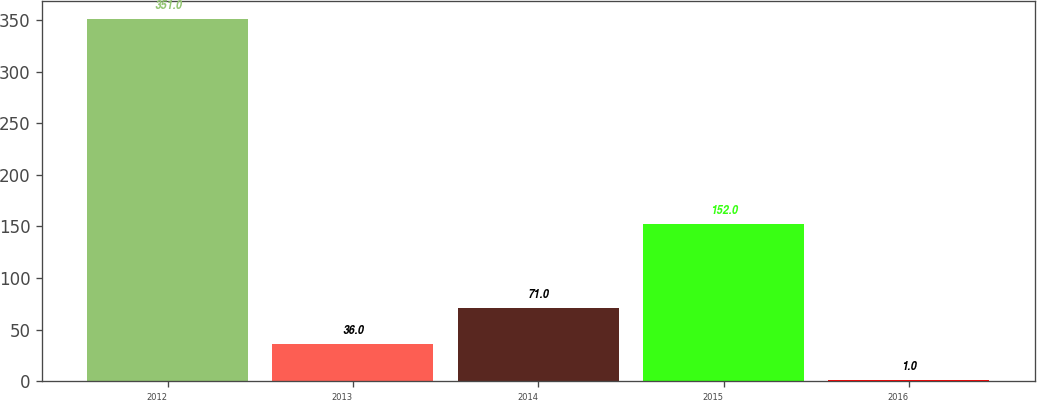<chart> <loc_0><loc_0><loc_500><loc_500><bar_chart><fcel>2012<fcel>2013<fcel>2014<fcel>2015<fcel>2016<nl><fcel>351<fcel>36<fcel>71<fcel>152<fcel>1<nl></chart> 